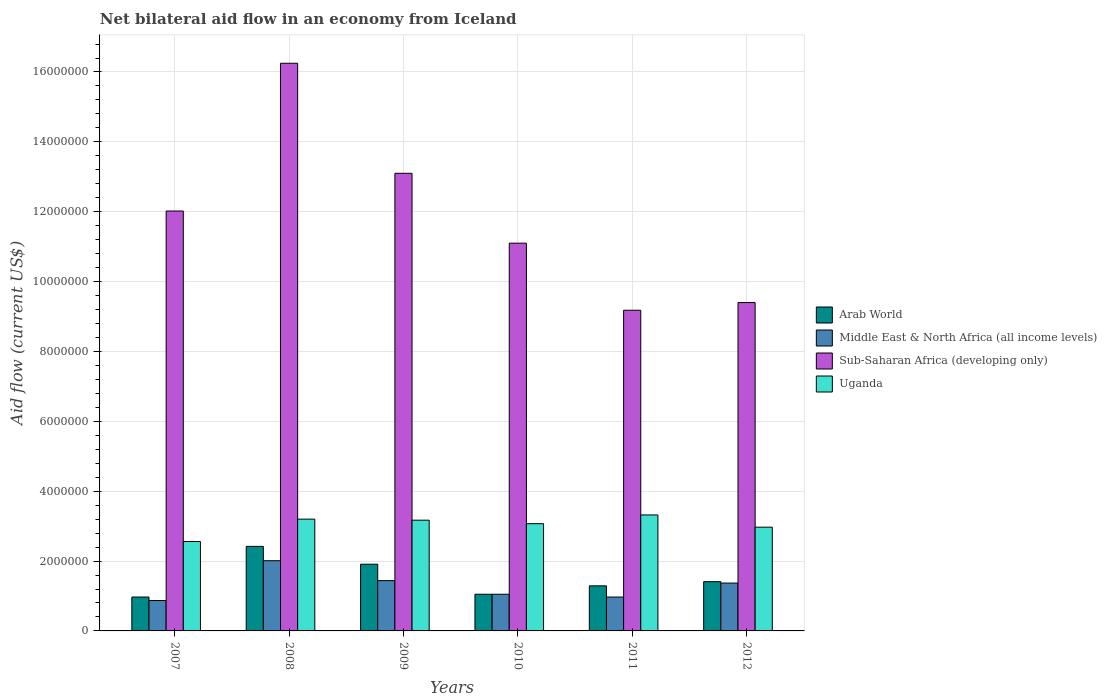How many different coloured bars are there?
Give a very brief answer. 4. Are the number of bars per tick equal to the number of legend labels?
Give a very brief answer. Yes. How many bars are there on the 3rd tick from the left?
Your answer should be very brief. 4. What is the label of the 4th group of bars from the left?
Provide a short and direct response. 2010. What is the net bilateral aid flow in Sub-Saharan Africa (developing only) in 2010?
Provide a short and direct response. 1.11e+07. Across all years, what is the maximum net bilateral aid flow in Middle East & North Africa (all income levels)?
Offer a very short reply. 2.01e+06. Across all years, what is the minimum net bilateral aid flow in Sub-Saharan Africa (developing only)?
Your answer should be very brief. 9.18e+06. What is the total net bilateral aid flow in Sub-Saharan Africa (developing only) in the graph?
Give a very brief answer. 7.10e+07. What is the difference between the net bilateral aid flow in Uganda in 2008 and the net bilateral aid flow in Middle East & North Africa (all income levels) in 2012?
Offer a terse response. 1.83e+06. What is the average net bilateral aid flow in Arab World per year?
Your answer should be very brief. 1.51e+06. In the year 2007, what is the difference between the net bilateral aid flow in Uganda and net bilateral aid flow in Arab World?
Offer a terse response. 1.59e+06. What is the ratio of the net bilateral aid flow in Sub-Saharan Africa (developing only) in 2010 to that in 2011?
Provide a short and direct response. 1.21. Is the net bilateral aid flow in Middle East & North Africa (all income levels) in 2011 less than that in 2012?
Your answer should be compact. Yes. Is the difference between the net bilateral aid flow in Uganda in 2008 and 2009 greater than the difference between the net bilateral aid flow in Arab World in 2008 and 2009?
Your response must be concise. No. What is the difference between the highest and the second highest net bilateral aid flow in Middle East & North Africa (all income levels)?
Provide a succinct answer. 5.70e+05. What is the difference between the highest and the lowest net bilateral aid flow in Uganda?
Keep it short and to the point. 7.60e+05. What does the 1st bar from the left in 2008 represents?
Ensure brevity in your answer.  Arab World. What does the 3rd bar from the right in 2010 represents?
Provide a short and direct response. Middle East & North Africa (all income levels). Are all the bars in the graph horizontal?
Offer a terse response. No. How many years are there in the graph?
Offer a very short reply. 6. Are the values on the major ticks of Y-axis written in scientific E-notation?
Give a very brief answer. No. Does the graph contain grids?
Provide a succinct answer. Yes. Where does the legend appear in the graph?
Your answer should be compact. Center right. How many legend labels are there?
Ensure brevity in your answer.  4. What is the title of the graph?
Provide a succinct answer. Net bilateral aid flow in an economy from Iceland. Does "Northern Mariana Islands" appear as one of the legend labels in the graph?
Ensure brevity in your answer.  No. What is the Aid flow (current US$) of Arab World in 2007?
Ensure brevity in your answer.  9.70e+05. What is the Aid flow (current US$) of Middle East & North Africa (all income levels) in 2007?
Provide a short and direct response. 8.70e+05. What is the Aid flow (current US$) in Sub-Saharan Africa (developing only) in 2007?
Offer a very short reply. 1.20e+07. What is the Aid flow (current US$) in Uganda in 2007?
Give a very brief answer. 2.56e+06. What is the Aid flow (current US$) in Arab World in 2008?
Ensure brevity in your answer.  2.42e+06. What is the Aid flow (current US$) in Middle East & North Africa (all income levels) in 2008?
Keep it short and to the point. 2.01e+06. What is the Aid flow (current US$) in Sub-Saharan Africa (developing only) in 2008?
Give a very brief answer. 1.62e+07. What is the Aid flow (current US$) of Uganda in 2008?
Offer a very short reply. 3.20e+06. What is the Aid flow (current US$) in Arab World in 2009?
Your answer should be compact. 1.91e+06. What is the Aid flow (current US$) in Middle East & North Africa (all income levels) in 2009?
Your response must be concise. 1.44e+06. What is the Aid flow (current US$) of Sub-Saharan Africa (developing only) in 2009?
Offer a very short reply. 1.31e+07. What is the Aid flow (current US$) in Uganda in 2009?
Keep it short and to the point. 3.17e+06. What is the Aid flow (current US$) of Arab World in 2010?
Offer a terse response. 1.05e+06. What is the Aid flow (current US$) of Middle East & North Africa (all income levels) in 2010?
Provide a short and direct response. 1.05e+06. What is the Aid flow (current US$) in Sub-Saharan Africa (developing only) in 2010?
Offer a very short reply. 1.11e+07. What is the Aid flow (current US$) in Uganda in 2010?
Your answer should be compact. 3.07e+06. What is the Aid flow (current US$) of Arab World in 2011?
Keep it short and to the point. 1.29e+06. What is the Aid flow (current US$) in Middle East & North Africa (all income levels) in 2011?
Keep it short and to the point. 9.70e+05. What is the Aid flow (current US$) in Sub-Saharan Africa (developing only) in 2011?
Your answer should be compact. 9.18e+06. What is the Aid flow (current US$) of Uganda in 2011?
Make the answer very short. 3.32e+06. What is the Aid flow (current US$) of Arab World in 2012?
Ensure brevity in your answer.  1.41e+06. What is the Aid flow (current US$) of Middle East & North Africa (all income levels) in 2012?
Offer a very short reply. 1.37e+06. What is the Aid flow (current US$) in Sub-Saharan Africa (developing only) in 2012?
Provide a succinct answer. 9.40e+06. What is the Aid flow (current US$) in Uganda in 2012?
Your response must be concise. 2.97e+06. Across all years, what is the maximum Aid flow (current US$) of Arab World?
Your answer should be very brief. 2.42e+06. Across all years, what is the maximum Aid flow (current US$) of Middle East & North Africa (all income levels)?
Your response must be concise. 2.01e+06. Across all years, what is the maximum Aid flow (current US$) in Sub-Saharan Africa (developing only)?
Provide a short and direct response. 1.62e+07. Across all years, what is the maximum Aid flow (current US$) of Uganda?
Give a very brief answer. 3.32e+06. Across all years, what is the minimum Aid flow (current US$) of Arab World?
Ensure brevity in your answer.  9.70e+05. Across all years, what is the minimum Aid flow (current US$) of Middle East & North Africa (all income levels)?
Make the answer very short. 8.70e+05. Across all years, what is the minimum Aid flow (current US$) in Sub-Saharan Africa (developing only)?
Offer a very short reply. 9.18e+06. Across all years, what is the minimum Aid flow (current US$) in Uganda?
Provide a short and direct response. 2.56e+06. What is the total Aid flow (current US$) of Arab World in the graph?
Make the answer very short. 9.05e+06. What is the total Aid flow (current US$) of Middle East & North Africa (all income levels) in the graph?
Provide a succinct answer. 7.71e+06. What is the total Aid flow (current US$) of Sub-Saharan Africa (developing only) in the graph?
Keep it short and to the point. 7.10e+07. What is the total Aid flow (current US$) of Uganda in the graph?
Ensure brevity in your answer.  1.83e+07. What is the difference between the Aid flow (current US$) of Arab World in 2007 and that in 2008?
Give a very brief answer. -1.45e+06. What is the difference between the Aid flow (current US$) of Middle East & North Africa (all income levels) in 2007 and that in 2008?
Provide a succinct answer. -1.14e+06. What is the difference between the Aid flow (current US$) of Sub-Saharan Africa (developing only) in 2007 and that in 2008?
Your answer should be very brief. -4.23e+06. What is the difference between the Aid flow (current US$) in Uganda in 2007 and that in 2008?
Ensure brevity in your answer.  -6.40e+05. What is the difference between the Aid flow (current US$) of Arab World in 2007 and that in 2009?
Provide a succinct answer. -9.40e+05. What is the difference between the Aid flow (current US$) in Middle East & North Africa (all income levels) in 2007 and that in 2009?
Provide a succinct answer. -5.70e+05. What is the difference between the Aid flow (current US$) of Sub-Saharan Africa (developing only) in 2007 and that in 2009?
Your response must be concise. -1.08e+06. What is the difference between the Aid flow (current US$) in Uganda in 2007 and that in 2009?
Offer a terse response. -6.10e+05. What is the difference between the Aid flow (current US$) of Arab World in 2007 and that in 2010?
Ensure brevity in your answer.  -8.00e+04. What is the difference between the Aid flow (current US$) of Sub-Saharan Africa (developing only) in 2007 and that in 2010?
Ensure brevity in your answer.  9.20e+05. What is the difference between the Aid flow (current US$) of Uganda in 2007 and that in 2010?
Your answer should be very brief. -5.10e+05. What is the difference between the Aid flow (current US$) in Arab World in 2007 and that in 2011?
Your response must be concise. -3.20e+05. What is the difference between the Aid flow (current US$) of Sub-Saharan Africa (developing only) in 2007 and that in 2011?
Ensure brevity in your answer.  2.84e+06. What is the difference between the Aid flow (current US$) of Uganda in 2007 and that in 2011?
Provide a succinct answer. -7.60e+05. What is the difference between the Aid flow (current US$) of Arab World in 2007 and that in 2012?
Give a very brief answer. -4.40e+05. What is the difference between the Aid flow (current US$) of Middle East & North Africa (all income levels) in 2007 and that in 2012?
Offer a very short reply. -5.00e+05. What is the difference between the Aid flow (current US$) in Sub-Saharan Africa (developing only) in 2007 and that in 2012?
Your answer should be compact. 2.62e+06. What is the difference between the Aid flow (current US$) in Uganda in 2007 and that in 2012?
Give a very brief answer. -4.10e+05. What is the difference between the Aid flow (current US$) of Arab World in 2008 and that in 2009?
Offer a terse response. 5.10e+05. What is the difference between the Aid flow (current US$) in Middle East & North Africa (all income levels) in 2008 and that in 2009?
Ensure brevity in your answer.  5.70e+05. What is the difference between the Aid flow (current US$) of Sub-Saharan Africa (developing only) in 2008 and that in 2009?
Your response must be concise. 3.15e+06. What is the difference between the Aid flow (current US$) in Uganda in 2008 and that in 2009?
Your answer should be compact. 3.00e+04. What is the difference between the Aid flow (current US$) in Arab World in 2008 and that in 2010?
Keep it short and to the point. 1.37e+06. What is the difference between the Aid flow (current US$) of Middle East & North Africa (all income levels) in 2008 and that in 2010?
Ensure brevity in your answer.  9.60e+05. What is the difference between the Aid flow (current US$) of Sub-Saharan Africa (developing only) in 2008 and that in 2010?
Provide a short and direct response. 5.15e+06. What is the difference between the Aid flow (current US$) of Uganda in 2008 and that in 2010?
Offer a very short reply. 1.30e+05. What is the difference between the Aid flow (current US$) in Arab World in 2008 and that in 2011?
Provide a succinct answer. 1.13e+06. What is the difference between the Aid flow (current US$) of Middle East & North Africa (all income levels) in 2008 and that in 2011?
Your answer should be compact. 1.04e+06. What is the difference between the Aid flow (current US$) of Sub-Saharan Africa (developing only) in 2008 and that in 2011?
Offer a terse response. 7.07e+06. What is the difference between the Aid flow (current US$) of Arab World in 2008 and that in 2012?
Give a very brief answer. 1.01e+06. What is the difference between the Aid flow (current US$) of Middle East & North Africa (all income levels) in 2008 and that in 2012?
Offer a very short reply. 6.40e+05. What is the difference between the Aid flow (current US$) in Sub-Saharan Africa (developing only) in 2008 and that in 2012?
Ensure brevity in your answer.  6.85e+06. What is the difference between the Aid flow (current US$) of Uganda in 2008 and that in 2012?
Keep it short and to the point. 2.30e+05. What is the difference between the Aid flow (current US$) in Arab World in 2009 and that in 2010?
Your response must be concise. 8.60e+05. What is the difference between the Aid flow (current US$) in Sub-Saharan Africa (developing only) in 2009 and that in 2010?
Your answer should be very brief. 2.00e+06. What is the difference between the Aid flow (current US$) of Uganda in 2009 and that in 2010?
Ensure brevity in your answer.  1.00e+05. What is the difference between the Aid flow (current US$) of Arab World in 2009 and that in 2011?
Provide a succinct answer. 6.20e+05. What is the difference between the Aid flow (current US$) in Middle East & North Africa (all income levels) in 2009 and that in 2011?
Offer a very short reply. 4.70e+05. What is the difference between the Aid flow (current US$) of Sub-Saharan Africa (developing only) in 2009 and that in 2011?
Your response must be concise. 3.92e+06. What is the difference between the Aid flow (current US$) in Sub-Saharan Africa (developing only) in 2009 and that in 2012?
Provide a short and direct response. 3.70e+06. What is the difference between the Aid flow (current US$) in Uganda in 2009 and that in 2012?
Your answer should be very brief. 2.00e+05. What is the difference between the Aid flow (current US$) of Arab World in 2010 and that in 2011?
Offer a very short reply. -2.40e+05. What is the difference between the Aid flow (current US$) of Sub-Saharan Africa (developing only) in 2010 and that in 2011?
Provide a short and direct response. 1.92e+06. What is the difference between the Aid flow (current US$) of Uganda in 2010 and that in 2011?
Make the answer very short. -2.50e+05. What is the difference between the Aid flow (current US$) of Arab World in 2010 and that in 2012?
Your answer should be very brief. -3.60e+05. What is the difference between the Aid flow (current US$) in Middle East & North Africa (all income levels) in 2010 and that in 2012?
Provide a short and direct response. -3.20e+05. What is the difference between the Aid flow (current US$) of Sub-Saharan Africa (developing only) in 2010 and that in 2012?
Your response must be concise. 1.70e+06. What is the difference between the Aid flow (current US$) of Uganda in 2010 and that in 2012?
Provide a succinct answer. 1.00e+05. What is the difference between the Aid flow (current US$) of Arab World in 2011 and that in 2012?
Give a very brief answer. -1.20e+05. What is the difference between the Aid flow (current US$) in Middle East & North Africa (all income levels) in 2011 and that in 2012?
Your answer should be compact. -4.00e+05. What is the difference between the Aid flow (current US$) in Sub-Saharan Africa (developing only) in 2011 and that in 2012?
Keep it short and to the point. -2.20e+05. What is the difference between the Aid flow (current US$) of Arab World in 2007 and the Aid flow (current US$) of Middle East & North Africa (all income levels) in 2008?
Your answer should be compact. -1.04e+06. What is the difference between the Aid flow (current US$) of Arab World in 2007 and the Aid flow (current US$) of Sub-Saharan Africa (developing only) in 2008?
Offer a terse response. -1.53e+07. What is the difference between the Aid flow (current US$) of Arab World in 2007 and the Aid flow (current US$) of Uganda in 2008?
Give a very brief answer. -2.23e+06. What is the difference between the Aid flow (current US$) of Middle East & North Africa (all income levels) in 2007 and the Aid flow (current US$) of Sub-Saharan Africa (developing only) in 2008?
Give a very brief answer. -1.54e+07. What is the difference between the Aid flow (current US$) of Middle East & North Africa (all income levels) in 2007 and the Aid flow (current US$) of Uganda in 2008?
Your answer should be compact. -2.33e+06. What is the difference between the Aid flow (current US$) of Sub-Saharan Africa (developing only) in 2007 and the Aid flow (current US$) of Uganda in 2008?
Your answer should be very brief. 8.82e+06. What is the difference between the Aid flow (current US$) in Arab World in 2007 and the Aid flow (current US$) in Middle East & North Africa (all income levels) in 2009?
Give a very brief answer. -4.70e+05. What is the difference between the Aid flow (current US$) of Arab World in 2007 and the Aid flow (current US$) of Sub-Saharan Africa (developing only) in 2009?
Offer a very short reply. -1.21e+07. What is the difference between the Aid flow (current US$) of Arab World in 2007 and the Aid flow (current US$) of Uganda in 2009?
Offer a terse response. -2.20e+06. What is the difference between the Aid flow (current US$) of Middle East & North Africa (all income levels) in 2007 and the Aid flow (current US$) of Sub-Saharan Africa (developing only) in 2009?
Offer a terse response. -1.22e+07. What is the difference between the Aid flow (current US$) of Middle East & North Africa (all income levels) in 2007 and the Aid flow (current US$) of Uganda in 2009?
Your answer should be very brief. -2.30e+06. What is the difference between the Aid flow (current US$) of Sub-Saharan Africa (developing only) in 2007 and the Aid flow (current US$) of Uganda in 2009?
Your answer should be very brief. 8.85e+06. What is the difference between the Aid flow (current US$) in Arab World in 2007 and the Aid flow (current US$) in Middle East & North Africa (all income levels) in 2010?
Make the answer very short. -8.00e+04. What is the difference between the Aid flow (current US$) of Arab World in 2007 and the Aid flow (current US$) of Sub-Saharan Africa (developing only) in 2010?
Your answer should be compact. -1.01e+07. What is the difference between the Aid flow (current US$) of Arab World in 2007 and the Aid flow (current US$) of Uganda in 2010?
Your response must be concise. -2.10e+06. What is the difference between the Aid flow (current US$) in Middle East & North Africa (all income levels) in 2007 and the Aid flow (current US$) in Sub-Saharan Africa (developing only) in 2010?
Your answer should be compact. -1.02e+07. What is the difference between the Aid flow (current US$) in Middle East & North Africa (all income levels) in 2007 and the Aid flow (current US$) in Uganda in 2010?
Keep it short and to the point. -2.20e+06. What is the difference between the Aid flow (current US$) in Sub-Saharan Africa (developing only) in 2007 and the Aid flow (current US$) in Uganda in 2010?
Offer a very short reply. 8.95e+06. What is the difference between the Aid flow (current US$) of Arab World in 2007 and the Aid flow (current US$) of Middle East & North Africa (all income levels) in 2011?
Your answer should be very brief. 0. What is the difference between the Aid flow (current US$) in Arab World in 2007 and the Aid flow (current US$) in Sub-Saharan Africa (developing only) in 2011?
Give a very brief answer. -8.21e+06. What is the difference between the Aid flow (current US$) of Arab World in 2007 and the Aid flow (current US$) of Uganda in 2011?
Provide a succinct answer. -2.35e+06. What is the difference between the Aid flow (current US$) in Middle East & North Africa (all income levels) in 2007 and the Aid flow (current US$) in Sub-Saharan Africa (developing only) in 2011?
Your answer should be compact. -8.31e+06. What is the difference between the Aid flow (current US$) of Middle East & North Africa (all income levels) in 2007 and the Aid flow (current US$) of Uganda in 2011?
Keep it short and to the point. -2.45e+06. What is the difference between the Aid flow (current US$) in Sub-Saharan Africa (developing only) in 2007 and the Aid flow (current US$) in Uganda in 2011?
Your answer should be compact. 8.70e+06. What is the difference between the Aid flow (current US$) in Arab World in 2007 and the Aid flow (current US$) in Middle East & North Africa (all income levels) in 2012?
Your answer should be compact. -4.00e+05. What is the difference between the Aid flow (current US$) of Arab World in 2007 and the Aid flow (current US$) of Sub-Saharan Africa (developing only) in 2012?
Keep it short and to the point. -8.43e+06. What is the difference between the Aid flow (current US$) of Middle East & North Africa (all income levels) in 2007 and the Aid flow (current US$) of Sub-Saharan Africa (developing only) in 2012?
Ensure brevity in your answer.  -8.53e+06. What is the difference between the Aid flow (current US$) in Middle East & North Africa (all income levels) in 2007 and the Aid flow (current US$) in Uganda in 2012?
Give a very brief answer. -2.10e+06. What is the difference between the Aid flow (current US$) of Sub-Saharan Africa (developing only) in 2007 and the Aid flow (current US$) of Uganda in 2012?
Offer a very short reply. 9.05e+06. What is the difference between the Aid flow (current US$) in Arab World in 2008 and the Aid flow (current US$) in Middle East & North Africa (all income levels) in 2009?
Your response must be concise. 9.80e+05. What is the difference between the Aid flow (current US$) in Arab World in 2008 and the Aid flow (current US$) in Sub-Saharan Africa (developing only) in 2009?
Your answer should be very brief. -1.07e+07. What is the difference between the Aid flow (current US$) in Arab World in 2008 and the Aid flow (current US$) in Uganda in 2009?
Make the answer very short. -7.50e+05. What is the difference between the Aid flow (current US$) in Middle East & North Africa (all income levels) in 2008 and the Aid flow (current US$) in Sub-Saharan Africa (developing only) in 2009?
Ensure brevity in your answer.  -1.11e+07. What is the difference between the Aid flow (current US$) in Middle East & North Africa (all income levels) in 2008 and the Aid flow (current US$) in Uganda in 2009?
Your answer should be very brief. -1.16e+06. What is the difference between the Aid flow (current US$) in Sub-Saharan Africa (developing only) in 2008 and the Aid flow (current US$) in Uganda in 2009?
Your answer should be very brief. 1.31e+07. What is the difference between the Aid flow (current US$) in Arab World in 2008 and the Aid flow (current US$) in Middle East & North Africa (all income levels) in 2010?
Offer a very short reply. 1.37e+06. What is the difference between the Aid flow (current US$) of Arab World in 2008 and the Aid flow (current US$) of Sub-Saharan Africa (developing only) in 2010?
Make the answer very short. -8.68e+06. What is the difference between the Aid flow (current US$) of Arab World in 2008 and the Aid flow (current US$) of Uganda in 2010?
Provide a succinct answer. -6.50e+05. What is the difference between the Aid flow (current US$) in Middle East & North Africa (all income levels) in 2008 and the Aid flow (current US$) in Sub-Saharan Africa (developing only) in 2010?
Your answer should be very brief. -9.09e+06. What is the difference between the Aid flow (current US$) of Middle East & North Africa (all income levels) in 2008 and the Aid flow (current US$) of Uganda in 2010?
Offer a very short reply. -1.06e+06. What is the difference between the Aid flow (current US$) in Sub-Saharan Africa (developing only) in 2008 and the Aid flow (current US$) in Uganda in 2010?
Offer a very short reply. 1.32e+07. What is the difference between the Aid flow (current US$) of Arab World in 2008 and the Aid flow (current US$) of Middle East & North Africa (all income levels) in 2011?
Offer a very short reply. 1.45e+06. What is the difference between the Aid flow (current US$) in Arab World in 2008 and the Aid flow (current US$) in Sub-Saharan Africa (developing only) in 2011?
Your answer should be very brief. -6.76e+06. What is the difference between the Aid flow (current US$) of Arab World in 2008 and the Aid flow (current US$) of Uganda in 2011?
Offer a very short reply. -9.00e+05. What is the difference between the Aid flow (current US$) in Middle East & North Africa (all income levels) in 2008 and the Aid flow (current US$) in Sub-Saharan Africa (developing only) in 2011?
Keep it short and to the point. -7.17e+06. What is the difference between the Aid flow (current US$) in Middle East & North Africa (all income levels) in 2008 and the Aid flow (current US$) in Uganda in 2011?
Offer a terse response. -1.31e+06. What is the difference between the Aid flow (current US$) in Sub-Saharan Africa (developing only) in 2008 and the Aid flow (current US$) in Uganda in 2011?
Offer a very short reply. 1.29e+07. What is the difference between the Aid flow (current US$) in Arab World in 2008 and the Aid flow (current US$) in Middle East & North Africa (all income levels) in 2012?
Provide a succinct answer. 1.05e+06. What is the difference between the Aid flow (current US$) in Arab World in 2008 and the Aid flow (current US$) in Sub-Saharan Africa (developing only) in 2012?
Provide a succinct answer. -6.98e+06. What is the difference between the Aid flow (current US$) of Arab World in 2008 and the Aid flow (current US$) of Uganda in 2012?
Make the answer very short. -5.50e+05. What is the difference between the Aid flow (current US$) in Middle East & North Africa (all income levels) in 2008 and the Aid flow (current US$) in Sub-Saharan Africa (developing only) in 2012?
Keep it short and to the point. -7.39e+06. What is the difference between the Aid flow (current US$) in Middle East & North Africa (all income levels) in 2008 and the Aid flow (current US$) in Uganda in 2012?
Give a very brief answer. -9.60e+05. What is the difference between the Aid flow (current US$) of Sub-Saharan Africa (developing only) in 2008 and the Aid flow (current US$) of Uganda in 2012?
Provide a short and direct response. 1.33e+07. What is the difference between the Aid flow (current US$) in Arab World in 2009 and the Aid flow (current US$) in Middle East & North Africa (all income levels) in 2010?
Keep it short and to the point. 8.60e+05. What is the difference between the Aid flow (current US$) in Arab World in 2009 and the Aid flow (current US$) in Sub-Saharan Africa (developing only) in 2010?
Provide a succinct answer. -9.19e+06. What is the difference between the Aid flow (current US$) of Arab World in 2009 and the Aid flow (current US$) of Uganda in 2010?
Keep it short and to the point. -1.16e+06. What is the difference between the Aid flow (current US$) in Middle East & North Africa (all income levels) in 2009 and the Aid flow (current US$) in Sub-Saharan Africa (developing only) in 2010?
Your answer should be compact. -9.66e+06. What is the difference between the Aid flow (current US$) in Middle East & North Africa (all income levels) in 2009 and the Aid flow (current US$) in Uganda in 2010?
Offer a very short reply. -1.63e+06. What is the difference between the Aid flow (current US$) of Sub-Saharan Africa (developing only) in 2009 and the Aid flow (current US$) of Uganda in 2010?
Ensure brevity in your answer.  1.00e+07. What is the difference between the Aid flow (current US$) of Arab World in 2009 and the Aid flow (current US$) of Middle East & North Africa (all income levels) in 2011?
Provide a short and direct response. 9.40e+05. What is the difference between the Aid flow (current US$) of Arab World in 2009 and the Aid flow (current US$) of Sub-Saharan Africa (developing only) in 2011?
Your answer should be compact. -7.27e+06. What is the difference between the Aid flow (current US$) of Arab World in 2009 and the Aid flow (current US$) of Uganda in 2011?
Your answer should be very brief. -1.41e+06. What is the difference between the Aid flow (current US$) of Middle East & North Africa (all income levels) in 2009 and the Aid flow (current US$) of Sub-Saharan Africa (developing only) in 2011?
Provide a succinct answer. -7.74e+06. What is the difference between the Aid flow (current US$) of Middle East & North Africa (all income levels) in 2009 and the Aid flow (current US$) of Uganda in 2011?
Your answer should be compact. -1.88e+06. What is the difference between the Aid flow (current US$) of Sub-Saharan Africa (developing only) in 2009 and the Aid flow (current US$) of Uganda in 2011?
Keep it short and to the point. 9.78e+06. What is the difference between the Aid flow (current US$) of Arab World in 2009 and the Aid flow (current US$) of Middle East & North Africa (all income levels) in 2012?
Provide a succinct answer. 5.40e+05. What is the difference between the Aid flow (current US$) in Arab World in 2009 and the Aid flow (current US$) in Sub-Saharan Africa (developing only) in 2012?
Offer a very short reply. -7.49e+06. What is the difference between the Aid flow (current US$) of Arab World in 2009 and the Aid flow (current US$) of Uganda in 2012?
Give a very brief answer. -1.06e+06. What is the difference between the Aid flow (current US$) of Middle East & North Africa (all income levels) in 2009 and the Aid flow (current US$) of Sub-Saharan Africa (developing only) in 2012?
Your answer should be compact. -7.96e+06. What is the difference between the Aid flow (current US$) of Middle East & North Africa (all income levels) in 2009 and the Aid flow (current US$) of Uganda in 2012?
Your response must be concise. -1.53e+06. What is the difference between the Aid flow (current US$) of Sub-Saharan Africa (developing only) in 2009 and the Aid flow (current US$) of Uganda in 2012?
Make the answer very short. 1.01e+07. What is the difference between the Aid flow (current US$) in Arab World in 2010 and the Aid flow (current US$) in Middle East & North Africa (all income levels) in 2011?
Give a very brief answer. 8.00e+04. What is the difference between the Aid flow (current US$) of Arab World in 2010 and the Aid flow (current US$) of Sub-Saharan Africa (developing only) in 2011?
Offer a terse response. -8.13e+06. What is the difference between the Aid flow (current US$) of Arab World in 2010 and the Aid flow (current US$) of Uganda in 2011?
Make the answer very short. -2.27e+06. What is the difference between the Aid flow (current US$) of Middle East & North Africa (all income levels) in 2010 and the Aid flow (current US$) of Sub-Saharan Africa (developing only) in 2011?
Give a very brief answer. -8.13e+06. What is the difference between the Aid flow (current US$) in Middle East & North Africa (all income levels) in 2010 and the Aid flow (current US$) in Uganda in 2011?
Make the answer very short. -2.27e+06. What is the difference between the Aid flow (current US$) of Sub-Saharan Africa (developing only) in 2010 and the Aid flow (current US$) of Uganda in 2011?
Your answer should be very brief. 7.78e+06. What is the difference between the Aid flow (current US$) in Arab World in 2010 and the Aid flow (current US$) in Middle East & North Africa (all income levels) in 2012?
Your answer should be compact. -3.20e+05. What is the difference between the Aid flow (current US$) of Arab World in 2010 and the Aid flow (current US$) of Sub-Saharan Africa (developing only) in 2012?
Offer a very short reply. -8.35e+06. What is the difference between the Aid flow (current US$) in Arab World in 2010 and the Aid flow (current US$) in Uganda in 2012?
Offer a very short reply. -1.92e+06. What is the difference between the Aid flow (current US$) in Middle East & North Africa (all income levels) in 2010 and the Aid flow (current US$) in Sub-Saharan Africa (developing only) in 2012?
Provide a short and direct response. -8.35e+06. What is the difference between the Aid flow (current US$) of Middle East & North Africa (all income levels) in 2010 and the Aid flow (current US$) of Uganda in 2012?
Your response must be concise. -1.92e+06. What is the difference between the Aid flow (current US$) in Sub-Saharan Africa (developing only) in 2010 and the Aid flow (current US$) in Uganda in 2012?
Provide a succinct answer. 8.13e+06. What is the difference between the Aid flow (current US$) of Arab World in 2011 and the Aid flow (current US$) of Middle East & North Africa (all income levels) in 2012?
Offer a terse response. -8.00e+04. What is the difference between the Aid flow (current US$) of Arab World in 2011 and the Aid flow (current US$) of Sub-Saharan Africa (developing only) in 2012?
Give a very brief answer. -8.11e+06. What is the difference between the Aid flow (current US$) of Arab World in 2011 and the Aid flow (current US$) of Uganda in 2012?
Your response must be concise. -1.68e+06. What is the difference between the Aid flow (current US$) of Middle East & North Africa (all income levels) in 2011 and the Aid flow (current US$) of Sub-Saharan Africa (developing only) in 2012?
Make the answer very short. -8.43e+06. What is the difference between the Aid flow (current US$) of Middle East & North Africa (all income levels) in 2011 and the Aid flow (current US$) of Uganda in 2012?
Ensure brevity in your answer.  -2.00e+06. What is the difference between the Aid flow (current US$) of Sub-Saharan Africa (developing only) in 2011 and the Aid flow (current US$) of Uganda in 2012?
Offer a terse response. 6.21e+06. What is the average Aid flow (current US$) of Arab World per year?
Your answer should be very brief. 1.51e+06. What is the average Aid flow (current US$) of Middle East & North Africa (all income levels) per year?
Keep it short and to the point. 1.28e+06. What is the average Aid flow (current US$) in Sub-Saharan Africa (developing only) per year?
Keep it short and to the point. 1.18e+07. What is the average Aid flow (current US$) in Uganda per year?
Make the answer very short. 3.05e+06. In the year 2007, what is the difference between the Aid flow (current US$) of Arab World and Aid flow (current US$) of Middle East & North Africa (all income levels)?
Ensure brevity in your answer.  1.00e+05. In the year 2007, what is the difference between the Aid flow (current US$) in Arab World and Aid flow (current US$) in Sub-Saharan Africa (developing only)?
Give a very brief answer. -1.10e+07. In the year 2007, what is the difference between the Aid flow (current US$) of Arab World and Aid flow (current US$) of Uganda?
Keep it short and to the point. -1.59e+06. In the year 2007, what is the difference between the Aid flow (current US$) of Middle East & North Africa (all income levels) and Aid flow (current US$) of Sub-Saharan Africa (developing only)?
Make the answer very short. -1.12e+07. In the year 2007, what is the difference between the Aid flow (current US$) in Middle East & North Africa (all income levels) and Aid flow (current US$) in Uganda?
Give a very brief answer. -1.69e+06. In the year 2007, what is the difference between the Aid flow (current US$) in Sub-Saharan Africa (developing only) and Aid flow (current US$) in Uganda?
Provide a succinct answer. 9.46e+06. In the year 2008, what is the difference between the Aid flow (current US$) of Arab World and Aid flow (current US$) of Sub-Saharan Africa (developing only)?
Offer a very short reply. -1.38e+07. In the year 2008, what is the difference between the Aid flow (current US$) in Arab World and Aid flow (current US$) in Uganda?
Give a very brief answer. -7.80e+05. In the year 2008, what is the difference between the Aid flow (current US$) in Middle East & North Africa (all income levels) and Aid flow (current US$) in Sub-Saharan Africa (developing only)?
Ensure brevity in your answer.  -1.42e+07. In the year 2008, what is the difference between the Aid flow (current US$) of Middle East & North Africa (all income levels) and Aid flow (current US$) of Uganda?
Your answer should be very brief. -1.19e+06. In the year 2008, what is the difference between the Aid flow (current US$) of Sub-Saharan Africa (developing only) and Aid flow (current US$) of Uganda?
Your response must be concise. 1.30e+07. In the year 2009, what is the difference between the Aid flow (current US$) of Arab World and Aid flow (current US$) of Middle East & North Africa (all income levels)?
Your response must be concise. 4.70e+05. In the year 2009, what is the difference between the Aid flow (current US$) in Arab World and Aid flow (current US$) in Sub-Saharan Africa (developing only)?
Offer a very short reply. -1.12e+07. In the year 2009, what is the difference between the Aid flow (current US$) in Arab World and Aid flow (current US$) in Uganda?
Offer a very short reply. -1.26e+06. In the year 2009, what is the difference between the Aid flow (current US$) in Middle East & North Africa (all income levels) and Aid flow (current US$) in Sub-Saharan Africa (developing only)?
Offer a very short reply. -1.17e+07. In the year 2009, what is the difference between the Aid flow (current US$) of Middle East & North Africa (all income levels) and Aid flow (current US$) of Uganda?
Your answer should be very brief. -1.73e+06. In the year 2009, what is the difference between the Aid flow (current US$) in Sub-Saharan Africa (developing only) and Aid flow (current US$) in Uganda?
Your answer should be compact. 9.93e+06. In the year 2010, what is the difference between the Aid flow (current US$) of Arab World and Aid flow (current US$) of Middle East & North Africa (all income levels)?
Your answer should be compact. 0. In the year 2010, what is the difference between the Aid flow (current US$) of Arab World and Aid flow (current US$) of Sub-Saharan Africa (developing only)?
Offer a terse response. -1.00e+07. In the year 2010, what is the difference between the Aid flow (current US$) in Arab World and Aid flow (current US$) in Uganda?
Your response must be concise. -2.02e+06. In the year 2010, what is the difference between the Aid flow (current US$) of Middle East & North Africa (all income levels) and Aid flow (current US$) of Sub-Saharan Africa (developing only)?
Offer a terse response. -1.00e+07. In the year 2010, what is the difference between the Aid flow (current US$) in Middle East & North Africa (all income levels) and Aid flow (current US$) in Uganda?
Provide a succinct answer. -2.02e+06. In the year 2010, what is the difference between the Aid flow (current US$) of Sub-Saharan Africa (developing only) and Aid flow (current US$) of Uganda?
Give a very brief answer. 8.03e+06. In the year 2011, what is the difference between the Aid flow (current US$) in Arab World and Aid flow (current US$) in Sub-Saharan Africa (developing only)?
Keep it short and to the point. -7.89e+06. In the year 2011, what is the difference between the Aid flow (current US$) in Arab World and Aid flow (current US$) in Uganda?
Provide a short and direct response. -2.03e+06. In the year 2011, what is the difference between the Aid flow (current US$) in Middle East & North Africa (all income levels) and Aid flow (current US$) in Sub-Saharan Africa (developing only)?
Provide a short and direct response. -8.21e+06. In the year 2011, what is the difference between the Aid flow (current US$) in Middle East & North Africa (all income levels) and Aid flow (current US$) in Uganda?
Keep it short and to the point. -2.35e+06. In the year 2011, what is the difference between the Aid flow (current US$) of Sub-Saharan Africa (developing only) and Aid flow (current US$) of Uganda?
Make the answer very short. 5.86e+06. In the year 2012, what is the difference between the Aid flow (current US$) in Arab World and Aid flow (current US$) in Sub-Saharan Africa (developing only)?
Your answer should be compact. -7.99e+06. In the year 2012, what is the difference between the Aid flow (current US$) in Arab World and Aid flow (current US$) in Uganda?
Offer a terse response. -1.56e+06. In the year 2012, what is the difference between the Aid flow (current US$) of Middle East & North Africa (all income levels) and Aid flow (current US$) of Sub-Saharan Africa (developing only)?
Provide a succinct answer. -8.03e+06. In the year 2012, what is the difference between the Aid flow (current US$) of Middle East & North Africa (all income levels) and Aid flow (current US$) of Uganda?
Ensure brevity in your answer.  -1.60e+06. In the year 2012, what is the difference between the Aid flow (current US$) of Sub-Saharan Africa (developing only) and Aid flow (current US$) of Uganda?
Your response must be concise. 6.43e+06. What is the ratio of the Aid flow (current US$) in Arab World in 2007 to that in 2008?
Offer a very short reply. 0.4. What is the ratio of the Aid flow (current US$) of Middle East & North Africa (all income levels) in 2007 to that in 2008?
Make the answer very short. 0.43. What is the ratio of the Aid flow (current US$) of Sub-Saharan Africa (developing only) in 2007 to that in 2008?
Your response must be concise. 0.74. What is the ratio of the Aid flow (current US$) in Uganda in 2007 to that in 2008?
Ensure brevity in your answer.  0.8. What is the ratio of the Aid flow (current US$) of Arab World in 2007 to that in 2009?
Keep it short and to the point. 0.51. What is the ratio of the Aid flow (current US$) of Middle East & North Africa (all income levels) in 2007 to that in 2009?
Provide a short and direct response. 0.6. What is the ratio of the Aid flow (current US$) of Sub-Saharan Africa (developing only) in 2007 to that in 2009?
Provide a short and direct response. 0.92. What is the ratio of the Aid flow (current US$) of Uganda in 2007 to that in 2009?
Offer a very short reply. 0.81. What is the ratio of the Aid flow (current US$) of Arab World in 2007 to that in 2010?
Your answer should be compact. 0.92. What is the ratio of the Aid flow (current US$) of Middle East & North Africa (all income levels) in 2007 to that in 2010?
Provide a short and direct response. 0.83. What is the ratio of the Aid flow (current US$) of Sub-Saharan Africa (developing only) in 2007 to that in 2010?
Keep it short and to the point. 1.08. What is the ratio of the Aid flow (current US$) in Uganda in 2007 to that in 2010?
Your response must be concise. 0.83. What is the ratio of the Aid flow (current US$) in Arab World in 2007 to that in 2011?
Your answer should be compact. 0.75. What is the ratio of the Aid flow (current US$) in Middle East & North Africa (all income levels) in 2007 to that in 2011?
Your answer should be very brief. 0.9. What is the ratio of the Aid flow (current US$) in Sub-Saharan Africa (developing only) in 2007 to that in 2011?
Offer a terse response. 1.31. What is the ratio of the Aid flow (current US$) of Uganda in 2007 to that in 2011?
Offer a very short reply. 0.77. What is the ratio of the Aid flow (current US$) of Arab World in 2007 to that in 2012?
Provide a succinct answer. 0.69. What is the ratio of the Aid flow (current US$) in Middle East & North Africa (all income levels) in 2007 to that in 2012?
Provide a short and direct response. 0.64. What is the ratio of the Aid flow (current US$) in Sub-Saharan Africa (developing only) in 2007 to that in 2012?
Provide a short and direct response. 1.28. What is the ratio of the Aid flow (current US$) of Uganda in 2007 to that in 2012?
Your response must be concise. 0.86. What is the ratio of the Aid flow (current US$) of Arab World in 2008 to that in 2009?
Keep it short and to the point. 1.27. What is the ratio of the Aid flow (current US$) in Middle East & North Africa (all income levels) in 2008 to that in 2009?
Keep it short and to the point. 1.4. What is the ratio of the Aid flow (current US$) of Sub-Saharan Africa (developing only) in 2008 to that in 2009?
Your response must be concise. 1.24. What is the ratio of the Aid flow (current US$) in Uganda in 2008 to that in 2009?
Your response must be concise. 1.01. What is the ratio of the Aid flow (current US$) of Arab World in 2008 to that in 2010?
Give a very brief answer. 2.3. What is the ratio of the Aid flow (current US$) of Middle East & North Africa (all income levels) in 2008 to that in 2010?
Offer a terse response. 1.91. What is the ratio of the Aid flow (current US$) of Sub-Saharan Africa (developing only) in 2008 to that in 2010?
Make the answer very short. 1.46. What is the ratio of the Aid flow (current US$) in Uganda in 2008 to that in 2010?
Your response must be concise. 1.04. What is the ratio of the Aid flow (current US$) in Arab World in 2008 to that in 2011?
Offer a terse response. 1.88. What is the ratio of the Aid flow (current US$) of Middle East & North Africa (all income levels) in 2008 to that in 2011?
Ensure brevity in your answer.  2.07. What is the ratio of the Aid flow (current US$) of Sub-Saharan Africa (developing only) in 2008 to that in 2011?
Provide a succinct answer. 1.77. What is the ratio of the Aid flow (current US$) in Uganda in 2008 to that in 2011?
Ensure brevity in your answer.  0.96. What is the ratio of the Aid flow (current US$) in Arab World in 2008 to that in 2012?
Keep it short and to the point. 1.72. What is the ratio of the Aid flow (current US$) in Middle East & North Africa (all income levels) in 2008 to that in 2012?
Offer a very short reply. 1.47. What is the ratio of the Aid flow (current US$) in Sub-Saharan Africa (developing only) in 2008 to that in 2012?
Ensure brevity in your answer.  1.73. What is the ratio of the Aid flow (current US$) of Uganda in 2008 to that in 2012?
Provide a short and direct response. 1.08. What is the ratio of the Aid flow (current US$) of Arab World in 2009 to that in 2010?
Your answer should be compact. 1.82. What is the ratio of the Aid flow (current US$) in Middle East & North Africa (all income levels) in 2009 to that in 2010?
Offer a terse response. 1.37. What is the ratio of the Aid flow (current US$) of Sub-Saharan Africa (developing only) in 2009 to that in 2010?
Offer a terse response. 1.18. What is the ratio of the Aid flow (current US$) in Uganda in 2009 to that in 2010?
Your answer should be very brief. 1.03. What is the ratio of the Aid flow (current US$) of Arab World in 2009 to that in 2011?
Your answer should be compact. 1.48. What is the ratio of the Aid flow (current US$) of Middle East & North Africa (all income levels) in 2009 to that in 2011?
Offer a very short reply. 1.48. What is the ratio of the Aid flow (current US$) in Sub-Saharan Africa (developing only) in 2009 to that in 2011?
Offer a very short reply. 1.43. What is the ratio of the Aid flow (current US$) in Uganda in 2009 to that in 2011?
Make the answer very short. 0.95. What is the ratio of the Aid flow (current US$) of Arab World in 2009 to that in 2012?
Give a very brief answer. 1.35. What is the ratio of the Aid flow (current US$) in Middle East & North Africa (all income levels) in 2009 to that in 2012?
Give a very brief answer. 1.05. What is the ratio of the Aid flow (current US$) of Sub-Saharan Africa (developing only) in 2009 to that in 2012?
Ensure brevity in your answer.  1.39. What is the ratio of the Aid flow (current US$) in Uganda in 2009 to that in 2012?
Make the answer very short. 1.07. What is the ratio of the Aid flow (current US$) of Arab World in 2010 to that in 2011?
Make the answer very short. 0.81. What is the ratio of the Aid flow (current US$) of Middle East & North Africa (all income levels) in 2010 to that in 2011?
Provide a short and direct response. 1.08. What is the ratio of the Aid flow (current US$) in Sub-Saharan Africa (developing only) in 2010 to that in 2011?
Your response must be concise. 1.21. What is the ratio of the Aid flow (current US$) of Uganda in 2010 to that in 2011?
Offer a terse response. 0.92. What is the ratio of the Aid flow (current US$) in Arab World in 2010 to that in 2012?
Provide a short and direct response. 0.74. What is the ratio of the Aid flow (current US$) in Middle East & North Africa (all income levels) in 2010 to that in 2012?
Your answer should be compact. 0.77. What is the ratio of the Aid flow (current US$) of Sub-Saharan Africa (developing only) in 2010 to that in 2012?
Your response must be concise. 1.18. What is the ratio of the Aid flow (current US$) in Uganda in 2010 to that in 2012?
Your answer should be very brief. 1.03. What is the ratio of the Aid flow (current US$) in Arab World in 2011 to that in 2012?
Your answer should be very brief. 0.91. What is the ratio of the Aid flow (current US$) in Middle East & North Africa (all income levels) in 2011 to that in 2012?
Your answer should be very brief. 0.71. What is the ratio of the Aid flow (current US$) in Sub-Saharan Africa (developing only) in 2011 to that in 2012?
Offer a very short reply. 0.98. What is the ratio of the Aid flow (current US$) of Uganda in 2011 to that in 2012?
Provide a succinct answer. 1.12. What is the difference between the highest and the second highest Aid flow (current US$) of Arab World?
Provide a short and direct response. 5.10e+05. What is the difference between the highest and the second highest Aid flow (current US$) in Middle East & North Africa (all income levels)?
Offer a very short reply. 5.70e+05. What is the difference between the highest and the second highest Aid flow (current US$) in Sub-Saharan Africa (developing only)?
Your answer should be very brief. 3.15e+06. What is the difference between the highest and the lowest Aid flow (current US$) in Arab World?
Give a very brief answer. 1.45e+06. What is the difference between the highest and the lowest Aid flow (current US$) of Middle East & North Africa (all income levels)?
Provide a short and direct response. 1.14e+06. What is the difference between the highest and the lowest Aid flow (current US$) in Sub-Saharan Africa (developing only)?
Keep it short and to the point. 7.07e+06. What is the difference between the highest and the lowest Aid flow (current US$) of Uganda?
Ensure brevity in your answer.  7.60e+05. 